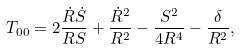Convert formula to latex. <formula><loc_0><loc_0><loc_500><loc_500>T _ { 0 0 } = 2 \frac { \dot { R } \dot { S } } { R S } + \frac { \dot { R } ^ { 2 } } { R ^ { 2 } } - \frac { S ^ { 2 } } { 4 R ^ { 4 } } - \frac { \delta } { R ^ { 2 } } ,</formula> 